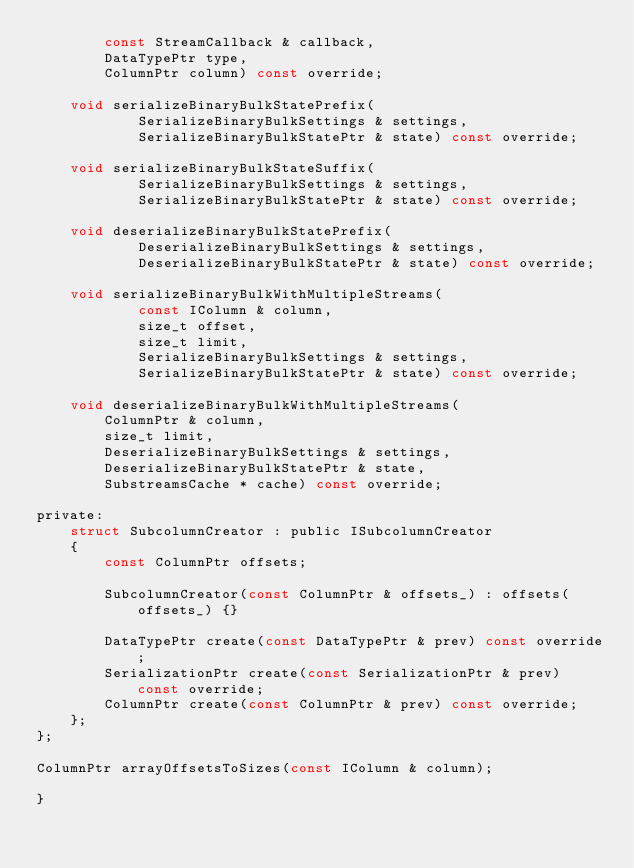<code> <loc_0><loc_0><loc_500><loc_500><_C_>        const StreamCallback & callback,
        DataTypePtr type,
        ColumnPtr column) const override;

    void serializeBinaryBulkStatePrefix(
            SerializeBinaryBulkSettings & settings,
            SerializeBinaryBulkStatePtr & state) const override;

    void serializeBinaryBulkStateSuffix(
            SerializeBinaryBulkSettings & settings,
            SerializeBinaryBulkStatePtr & state) const override;

    void deserializeBinaryBulkStatePrefix(
            DeserializeBinaryBulkSettings & settings,
            DeserializeBinaryBulkStatePtr & state) const override;

    void serializeBinaryBulkWithMultipleStreams(
            const IColumn & column,
            size_t offset,
            size_t limit,
            SerializeBinaryBulkSettings & settings,
            SerializeBinaryBulkStatePtr & state) const override;

    void deserializeBinaryBulkWithMultipleStreams(
        ColumnPtr & column,
        size_t limit,
        DeserializeBinaryBulkSettings & settings,
        DeserializeBinaryBulkStatePtr & state,
        SubstreamsCache * cache) const override;

private:
    struct SubcolumnCreator : public ISubcolumnCreator
    {
        const ColumnPtr offsets;

        SubcolumnCreator(const ColumnPtr & offsets_) : offsets(offsets_) {}

        DataTypePtr create(const DataTypePtr & prev) const override;
        SerializationPtr create(const SerializationPtr & prev) const override;
        ColumnPtr create(const ColumnPtr & prev) const override;
    };
};

ColumnPtr arrayOffsetsToSizes(const IColumn & column);

}
</code> 